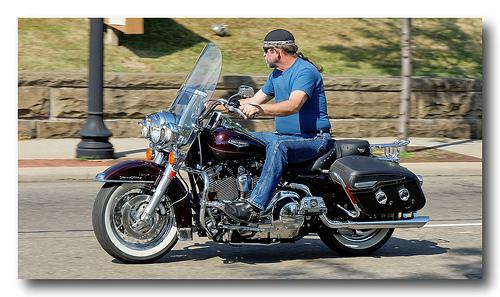Question: why are there shadows?
Choices:
A. Overcast.
B. It is sunny.
C. People around.
D. The trees.
Answer with the letter. Answer: B Question: what is the man riding?
Choices:
A. A bicycle.
B. A motorcycle.
C. A trike.
D. Horse.
Answer with the letter. Answer: B Question: who is on the motorcycle?
Choices:
A. A woman.
B. An officer.
C. The man.
D. A guy.
Answer with the letter. Answer: C Question: where is the man?
Choices:
A. On the hill.
B. Mountain side.
C. By the wind mill.
D. On the motorcycle.
Answer with the letter. Answer: D 